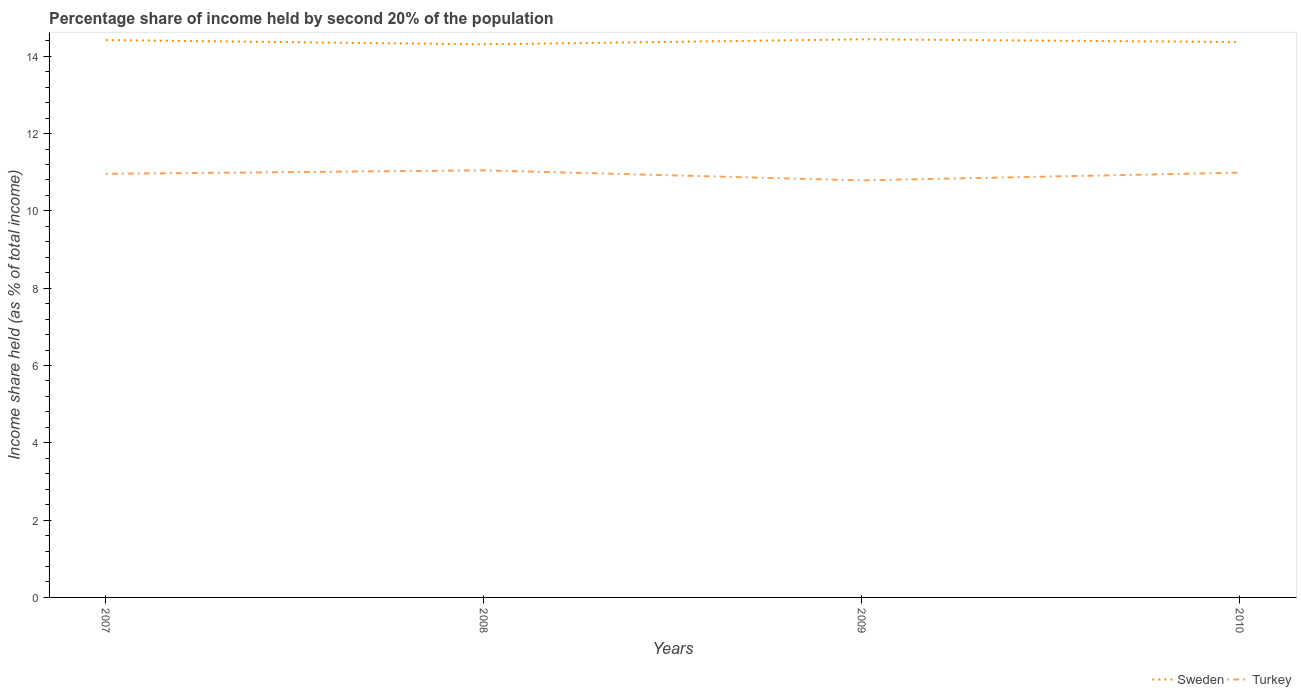Does the line corresponding to Sweden intersect with the line corresponding to Turkey?
Your answer should be very brief. No. Is the number of lines equal to the number of legend labels?
Keep it short and to the point. Yes. Across all years, what is the maximum share of income held by second 20% of the population in Turkey?
Keep it short and to the point. 10.79. In which year was the share of income held by second 20% of the population in Turkey maximum?
Your response must be concise. 2009. What is the total share of income held by second 20% of the population in Turkey in the graph?
Provide a succinct answer. 0.26. What is the difference between the highest and the second highest share of income held by second 20% of the population in Sweden?
Your answer should be compact. 0.13. What is the difference between the highest and the lowest share of income held by second 20% of the population in Turkey?
Your answer should be very brief. 3. How many lines are there?
Offer a terse response. 2. How many years are there in the graph?
Your answer should be very brief. 4. Does the graph contain any zero values?
Provide a succinct answer. No. Does the graph contain grids?
Keep it short and to the point. No. How many legend labels are there?
Offer a very short reply. 2. What is the title of the graph?
Provide a short and direct response. Percentage share of income held by second 20% of the population. Does "Bahrain" appear as one of the legend labels in the graph?
Offer a terse response. No. What is the label or title of the X-axis?
Give a very brief answer. Years. What is the label or title of the Y-axis?
Provide a succinct answer. Income share held (as % of total income). What is the Income share held (as % of total income) in Sweden in 2007?
Offer a very short reply. 14.42. What is the Income share held (as % of total income) in Turkey in 2007?
Give a very brief answer. 10.96. What is the Income share held (as % of total income) of Sweden in 2008?
Offer a very short reply. 14.31. What is the Income share held (as % of total income) in Turkey in 2008?
Offer a very short reply. 11.05. What is the Income share held (as % of total income) in Sweden in 2009?
Offer a very short reply. 14.44. What is the Income share held (as % of total income) in Turkey in 2009?
Your answer should be very brief. 10.79. What is the Income share held (as % of total income) of Sweden in 2010?
Give a very brief answer. 14.37. What is the Income share held (as % of total income) of Turkey in 2010?
Give a very brief answer. 10.99. Across all years, what is the maximum Income share held (as % of total income) in Sweden?
Offer a terse response. 14.44. Across all years, what is the maximum Income share held (as % of total income) in Turkey?
Ensure brevity in your answer.  11.05. Across all years, what is the minimum Income share held (as % of total income) in Sweden?
Your response must be concise. 14.31. Across all years, what is the minimum Income share held (as % of total income) of Turkey?
Make the answer very short. 10.79. What is the total Income share held (as % of total income) of Sweden in the graph?
Provide a succinct answer. 57.54. What is the total Income share held (as % of total income) of Turkey in the graph?
Offer a terse response. 43.79. What is the difference between the Income share held (as % of total income) in Sweden in 2007 and that in 2008?
Give a very brief answer. 0.11. What is the difference between the Income share held (as % of total income) of Turkey in 2007 and that in 2008?
Ensure brevity in your answer.  -0.09. What is the difference between the Income share held (as % of total income) in Sweden in 2007 and that in 2009?
Provide a short and direct response. -0.02. What is the difference between the Income share held (as % of total income) of Turkey in 2007 and that in 2009?
Give a very brief answer. 0.17. What is the difference between the Income share held (as % of total income) in Turkey in 2007 and that in 2010?
Your response must be concise. -0.03. What is the difference between the Income share held (as % of total income) of Sweden in 2008 and that in 2009?
Keep it short and to the point. -0.13. What is the difference between the Income share held (as % of total income) of Turkey in 2008 and that in 2009?
Provide a short and direct response. 0.26. What is the difference between the Income share held (as % of total income) in Sweden in 2008 and that in 2010?
Give a very brief answer. -0.06. What is the difference between the Income share held (as % of total income) of Turkey in 2008 and that in 2010?
Your response must be concise. 0.06. What is the difference between the Income share held (as % of total income) in Sweden in 2009 and that in 2010?
Make the answer very short. 0.07. What is the difference between the Income share held (as % of total income) of Sweden in 2007 and the Income share held (as % of total income) of Turkey in 2008?
Your answer should be compact. 3.37. What is the difference between the Income share held (as % of total income) of Sweden in 2007 and the Income share held (as % of total income) of Turkey in 2009?
Offer a very short reply. 3.63. What is the difference between the Income share held (as % of total income) in Sweden in 2007 and the Income share held (as % of total income) in Turkey in 2010?
Your answer should be compact. 3.43. What is the difference between the Income share held (as % of total income) in Sweden in 2008 and the Income share held (as % of total income) in Turkey in 2009?
Offer a very short reply. 3.52. What is the difference between the Income share held (as % of total income) of Sweden in 2008 and the Income share held (as % of total income) of Turkey in 2010?
Your answer should be compact. 3.32. What is the difference between the Income share held (as % of total income) in Sweden in 2009 and the Income share held (as % of total income) in Turkey in 2010?
Keep it short and to the point. 3.45. What is the average Income share held (as % of total income) of Sweden per year?
Offer a very short reply. 14.38. What is the average Income share held (as % of total income) in Turkey per year?
Ensure brevity in your answer.  10.95. In the year 2007, what is the difference between the Income share held (as % of total income) of Sweden and Income share held (as % of total income) of Turkey?
Provide a short and direct response. 3.46. In the year 2008, what is the difference between the Income share held (as % of total income) in Sweden and Income share held (as % of total income) in Turkey?
Keep it short and to the point. 3.26. In the year 2009, what is the difference between the Income share held (as % of total income) of Sweden and Income share held (as % of total income) of Turkey?
Ensure brevity in your answer.  3.65. In the year 2010, what is the difference between the Income share held (as % of total income) in Sweden and Income share held (as % of total income) in Turkey?
Provide a short and direct response. 3.38. What is the ratio of the Income share held (as % of total income) of Sweden in 2007 to that in 2008?
Keep it short and to the point. 1.01. What is the ratio of the Income share held (as % of total income) in Sweden in 2007 to that in 2009?
Your response must be concise. 1. What is the ratio of the Income share held (as % of total income) of Turkey in 2007 to that in 2009?
Offer a terse response. 1.02. What is the ratio of the Income share held (as % of total income) in Sweden in 2007 to that in 2010?
Provide a short and direct response. 1. What is the ratio of the Income share held (as % of total income) of Sweden in 2008 to that in 2009?
Ensure brevity in your answer.  0.99. What is the ratio of the Income share held (as % of total income) of Turkey in 2008 to that in 2009?
Your answer should be very brief. 1.02. What is the ratio of the Income share held (as % of total income) in Turkey in 2008 to that in 2010?
Make the answer very short. 1.01. What is the ratio of the Income share held (as % of total income) of Turkey in 2009 to that in 2010?
Provide a succinct answer. 0.98. What is the difference between the highest and the second highest Income share held (as % of total income) of Turkey?
Provide a succinct answer. 0.06. What is the difference between the highest and the lowest Income share held (as % of total income) in Sweden?
Provide a succinct answer. 0.13. What is the difference between the highest and the lowest Income share held (as % of total income) of Turkey?
Your answer should be compact. 0.26. 